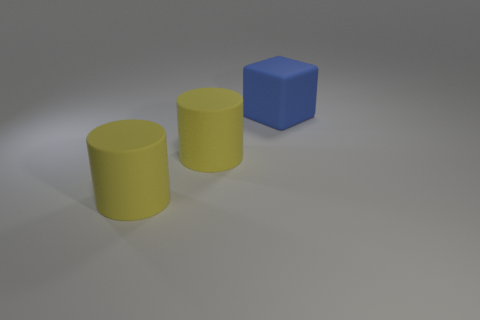Subtract all cylinders. How many objects are left? 1 Add 2 big objects. How many objects exist? 5 Subtract all green cubes. Subtract all purple balls. How many cubes are left? 1 Subtract all rubber objects. Subtract all tiny purple shiny objects. How many objects are left? 0 Add 1 big blue blocks. How many big blue blocks are left? 2 Add 3 big matte things. How many big matte things exist? 6 Subtract 1 yellow cylinders. How many objects are left? 2 